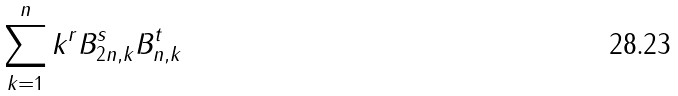Convert formula to latex. <formula><loc_0><loc_0><loc_500><loc_500>\sum _ { k = 1 } ^ { n } k ^ { r } B _ { 2 n , k } ^ { s } B _ { n , k } ^ { t }</formula> 